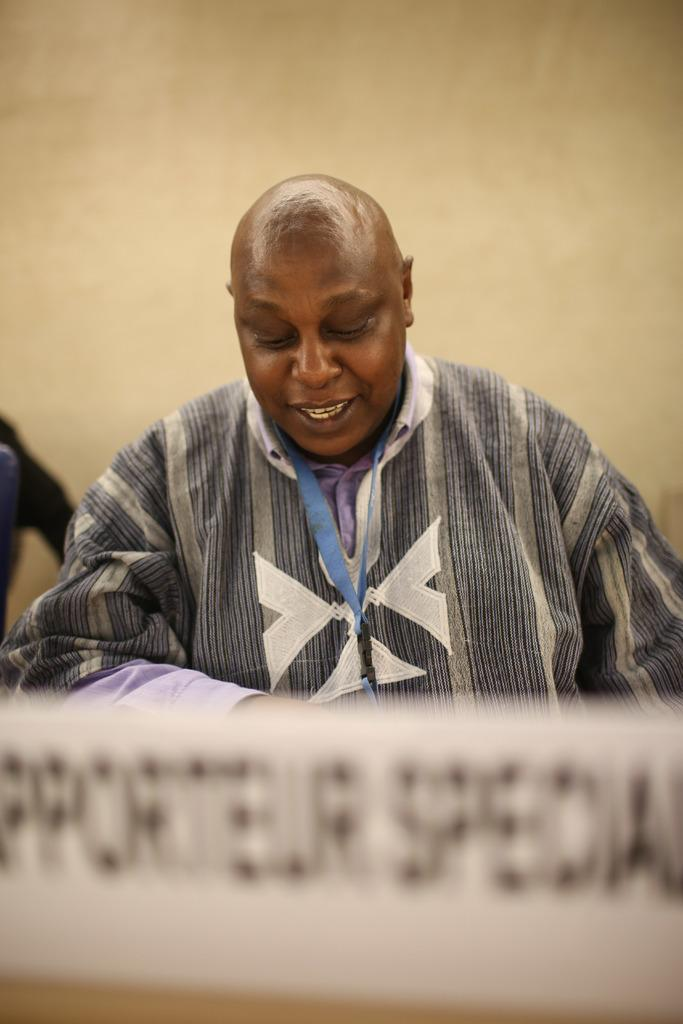What is placed on the table in the image? There is a name board on the table. Can you describe the person in the background? There is a person sitting in a chair in the background. What can be seen behind the person in the background? There is a wall visible in the background. What type of leather material is used for the boy's shoes in the image? There is no boy or shoes present in the image, so it is not possible to determine the type of leather material used. 